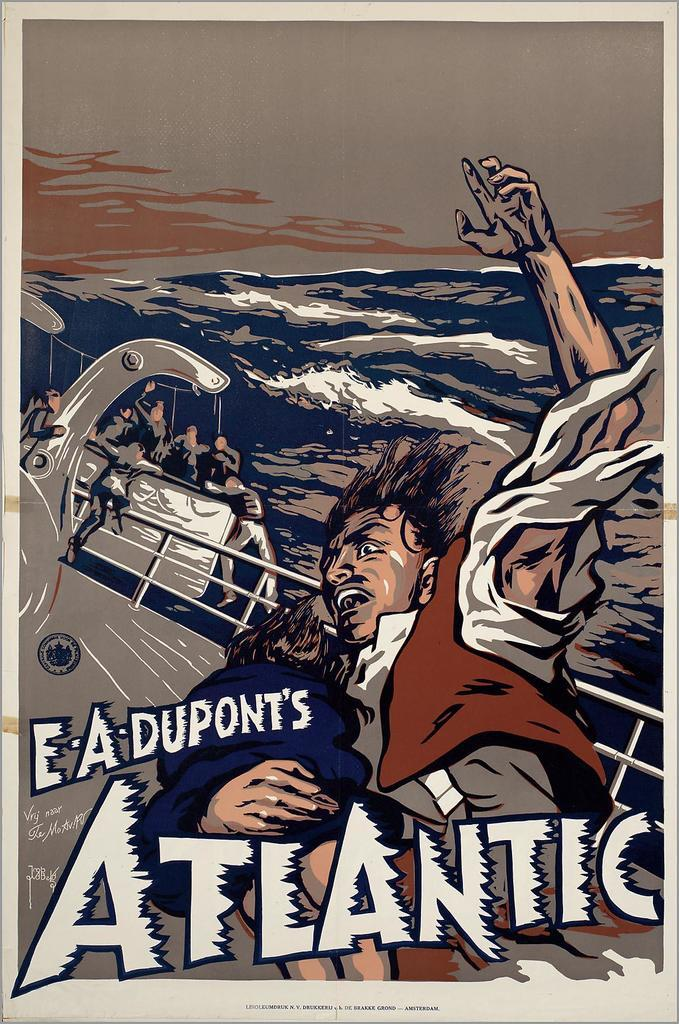<image>
Give a short and clear explanation of the subsequent image. A poster for E.A. Dupont's Atlantic showing a man about to go overboard. 